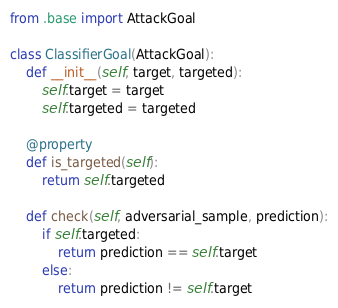<code> <loc_0><loc_0><loc_500><loc_500><_Python_>from .base import AttackGoal

class ClassifierGoal(AttackGoal):
    def __init__(self, target, targeted):
        self.target = target
        self.targeted = targeted
    
    @property
    def is_targeted(self):
        return self.targeted

    def check(self, adversarial_sample, prediction):
        if self.targeted:
            return prediction == self.target
        else:
            return prediction != self.target</code> 